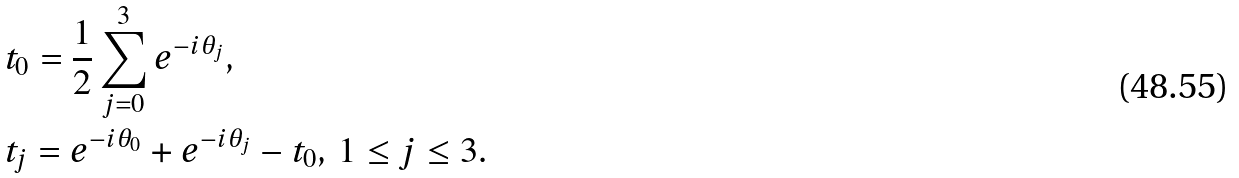Convert formula to latex. <formula><loc_0><loc_0><loc_500><loc_500>& t _ { 0 } = \frac { 1 } { 2 } \sum _ { j = 0 } ^ { 3 } e ^ { - i \theta _ { j } } , \\ & t _ { j } = e ^ { - i \theta _ { 0 } } + e ^ { - i \theta _ { j } } - t _ { 0 } , \, 1 \leq j \leq 3 .</formula> 